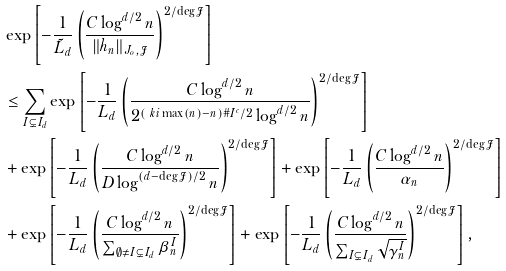Convert formula to latex. <formula><loc_0><loc_0><loc_500><loc_500>& \exp \left [ - \frac { 1 } { \tilde { L } _ { d } } \left ( \frac { C \log ^ { d / 2 } n } { \| h _ { n } \| _ { J _ { o } , \mathcal { J } } } \right ) ^ { 2 / \deg \mathcal { J } } \right ] \\ & \leq \sum _ { I \subsetneq I _ { d } } \exp \left [ - \frac { 1 } { L _ { d } } \left ( \frac { C \log ^ { d / 2 } n } { 2 ^ { ( \ k i \max ( n ) - n ) \# I ^ { c } / 2 } \log ^ { d / 2 } n } \right ) ^ { 2 / \deg \mathcal { J } } \right ] \\ & + \exp \left [ - \frac { 1 } { L _ { d } } \left ( \frac { C \log ^ { d / 2 } n } { D \log ^ { ( d - \deg \mathcal { J } ) / 2 } n } \right ) ^ { 2 / \deg \mathcal { J } } \right ] + \exp \left [ - \frac { 1 } { L _ { d } } \left ( \frac { C \log ^ { d / 2 } n } { \alpha _ { n } } \right ) ^ { 2 / \deg \mathcal { J } } \right ] \\ & + \exp \left [ - \frac { 1 } { L _ { d } } \left ( \frac { C \log ^ { d / 2 } n } { \sum _ { \emptyset \neq I \subsetneq I _ { d } } \beta _ { n } ^ { I } } \right ) ^ { 2 / \deg \mathcal { J } } \right ] + \exp \left [ - \frac { 1 } { L _ { d } } \left ( \frac { C \log ^ { d / 2 } n } { \sum _ { I \subsetneq I _ { d } } \sqrt { \gamma _ { n } ^ { I } } } \right ) ^ { 2 / \deg \mathcal { J } } \right ] ,</formula> 